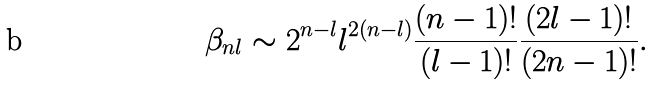<formula> <loc_0><loc_0><loc_500><loc_500>\beta _ { n l } \sim 2 ^ { n - l } l ^ { 2 ( n - l ) } \frac { ( n - 1 ) ! } { ( l - 1 ) ! } \frac { ( 2 l - 1 ) ! } { ( 2 n - 1 ) ! } .</formula> 